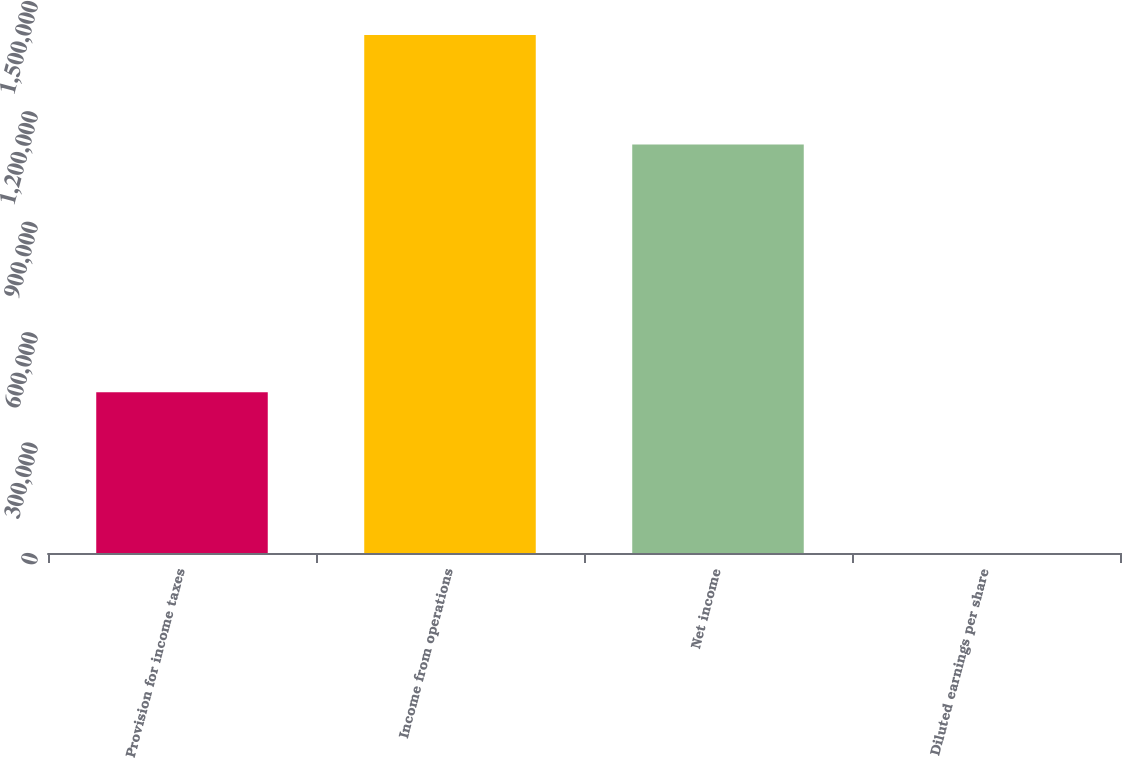Convert chart to OTSL. <chart><loc_0><loc_0><loc_500><loc_500><bar_chart><fcel>Provision for income taxes<fcel>Income from operations<fcel>Net income<fcel>Diluted earnings per share<nl><fcel>436889<fcel>1.40748e+06<fcel>1.11017e+06<fcel>0.78<nl></chart> 